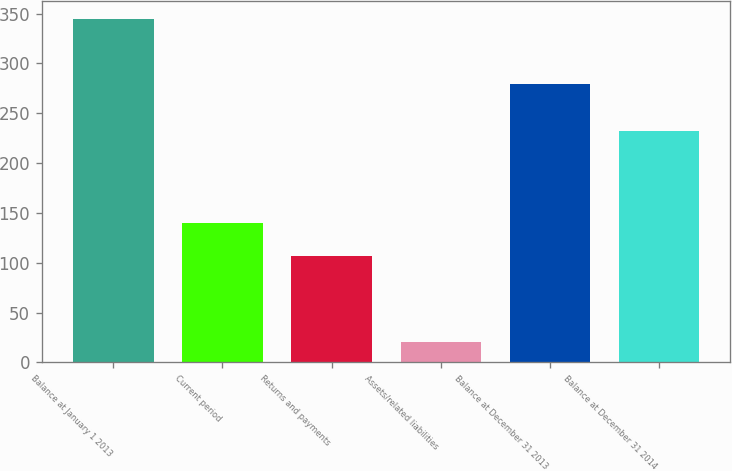<chart> <loc_0><loc_0><loc_500><loc_500><bar_chart><fcel>Balance at January 1 2013<fcel>Current period<fcel>Returns and payments<fcel>Assets/related liabilities<fcel>Balance at December 31 2013<fcel>Balance at December 31 2014<nl><fcel>345<fcel>139.5<fcel>107<fcel>20<fcel>279<fcel>232<nl></chart> 